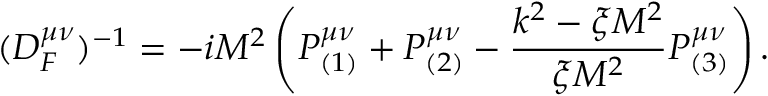Convert formula to latex. <formula><loc_0><loc_0><loc_500><loc_500>( D _ { F } ^ { \mu \nu } ) ^ { - 1 } = - i M ^ { 2 } \left ( P _ { ( 1 ) } ^ { \mu \nu } + P _ { ( 2 ) } ^ { \mu \nu } - \frac { k ^ { 2 } - \xi M ^ { 2 } } { \xi M ^ { 2 } } P _ { ( 3 ) } ^ { \mu \nu } \right ) .</formula> 